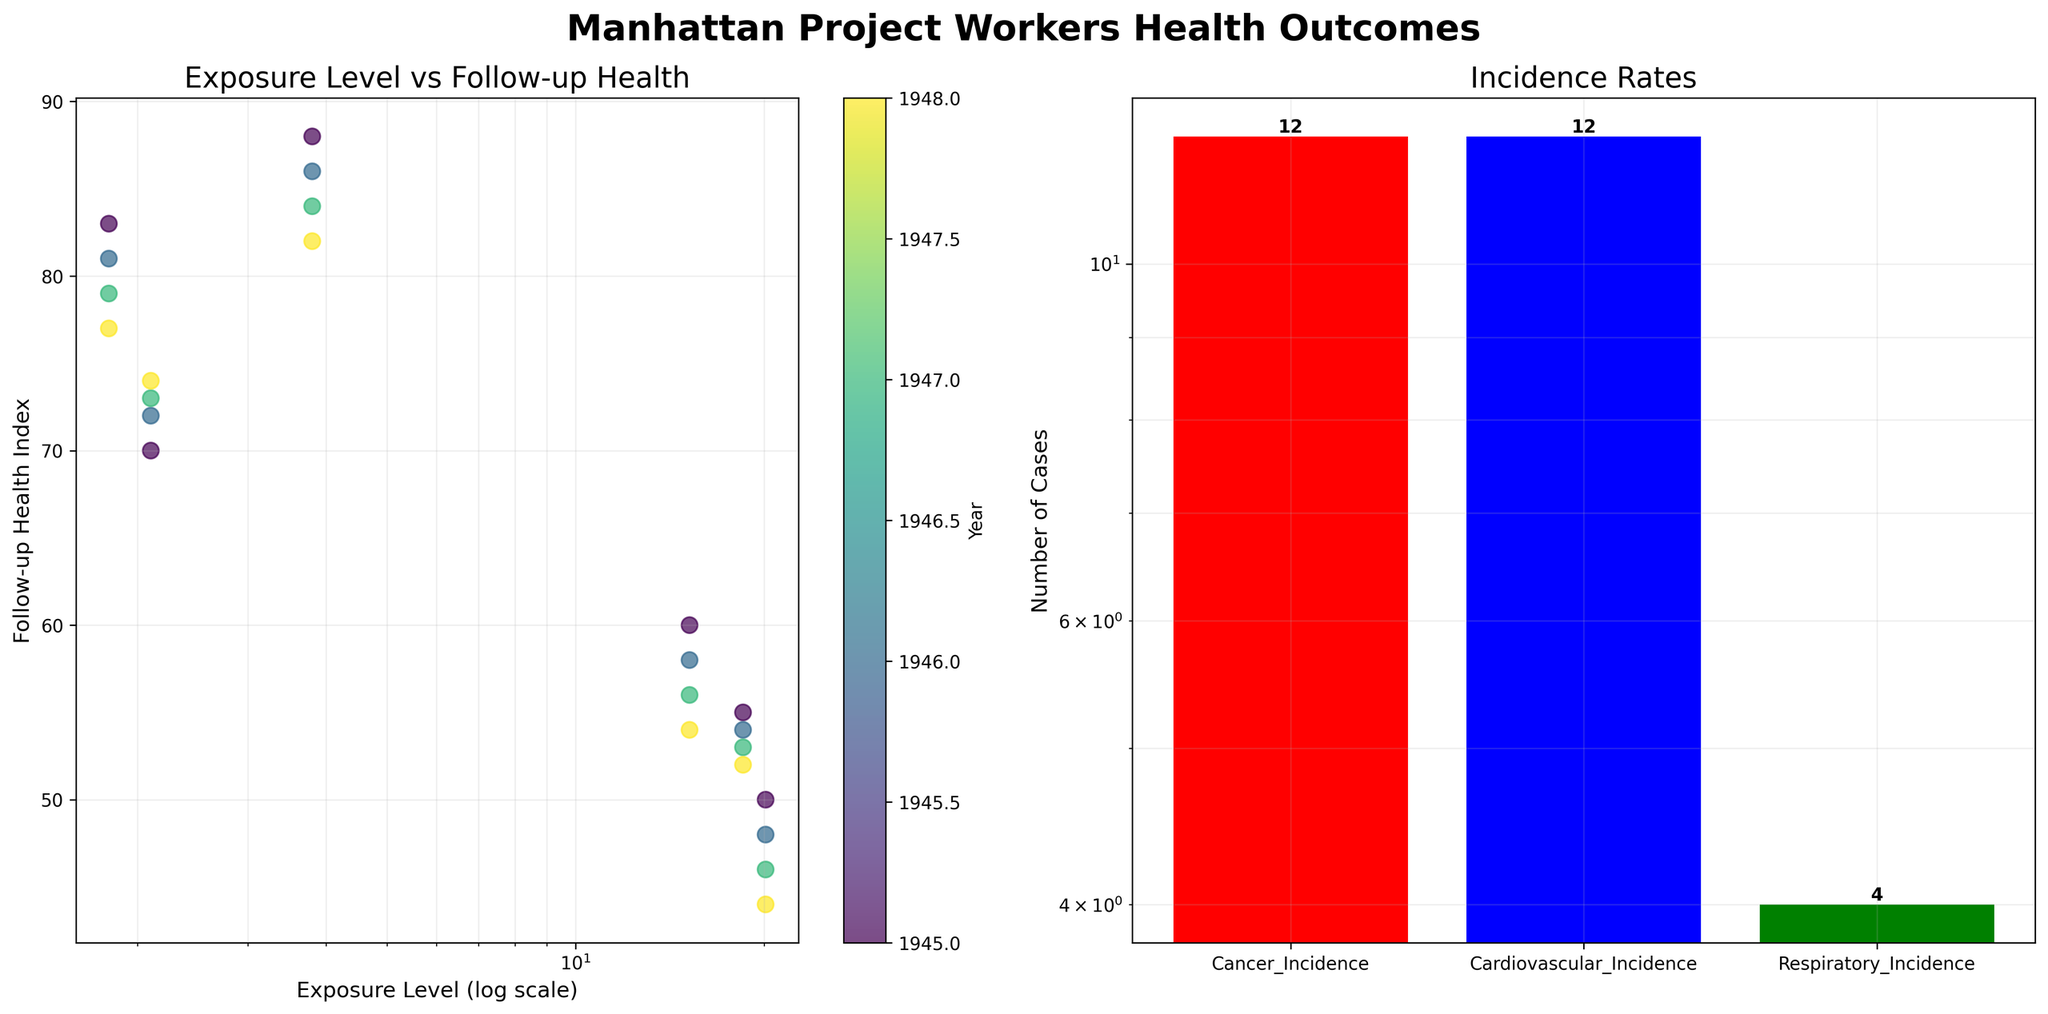What is the title of the figure? The title of the figure is written in a large, bold font at the top center of the figure. It provides an overall description of the entire figure.
Answer: Manhattan Project Workers Health Outcomes Which axis of the scatter plot is using a log scale? By examining the scatter plot, the x-axis for "Exposure Level" is visibly marked as using a logarithmic scale.
Answer: x-axis How many cancer incidence cases are shown in the bar chart? The bar chart on the right side of the figure represents different types of incidence cases with bars. The height of the red bar represents cancer incidences. There's also a number label on top of each bar indicating the total cases.
Answer: 8 Which year is associated with the highest follow-up health index in the scatter plot? By looking at the color gradient representing different years on the scatter plot, you can identify data points with the highest follow-up health index and compare their color shading. Data from earlier years are generally lighter.
Answer: 1945 What is the relationship between exposure level and follow-up health index in the first subplot? In the first subplot, as the exposure level increases (on a logarithmic scale), the follow-up health index predominantly decreases, indicating an inverse relationship.
Answer: Inverse relationship What is the sum of respiratory incidence cases across all years? The sum of respiratory incidence cases can be directly obtained by summing up the values represented by the green bar in the bar chart on the right side of the figure.
Answer: 4 Which incidence type has the highest number based on the bar chart, and how much higher is it compared to cardiovascular incidences? By comparing the heights and labels of the different bars on the bar chart, we observe the highest count and perform a subtraction with the count of cardiovascular incidences.
Answer: Cancer incidences; 4 Is there a visible trend in the follow-up health index of worker 1 across the years? By focusing on the data points corresponding to worker 1 (all with an exposure level of 2.1) in the scatter plot, we see the progression of the follow-up health index assigned different colors according to year.
Answer: Increasing trend What commonality exists between workers with the highest mortality rates? Examining the scatter and color correlation among mortality rates data, higher mortality rates are primarily associated with high exposure levels (20.1 and 18.5).
Answer: High exposure levels Which axis in the bar chart is using a log scale? By observing the scale marks and spacing on the bar chart axis, it becomes clear which uses a logarithmic scale. The spacing and smaller increments indicate the log scale.
Answer: y-axis 